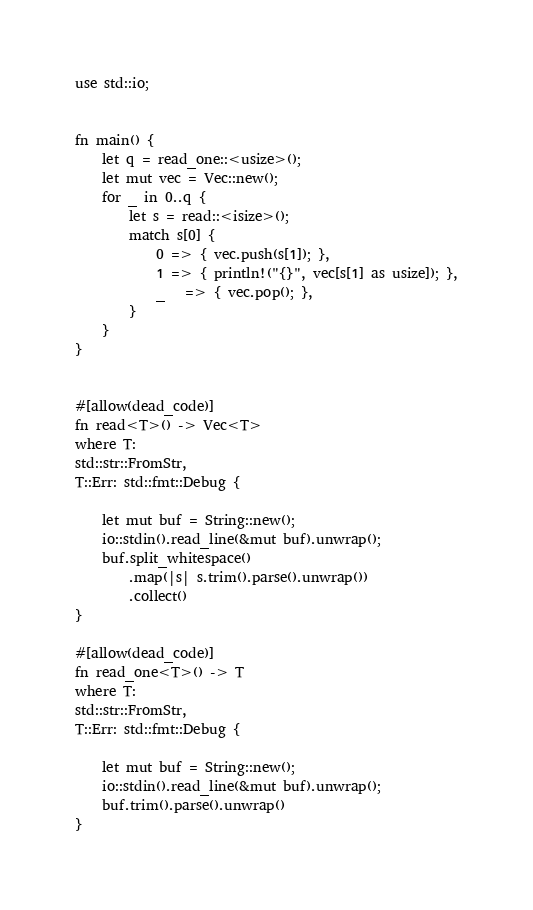<code> <loc_0><loc_0><loc_500><loc_500><_Rust_>use std::io;


fn main() {
    let q = read_one::<usize>();
    let mut vec = Vec::new();
    for _ in 0..q {
        let s = read::<isize>();
        match s[0] {
            0 => { vec.push(s[1]); },
            1 => { println!("{}", vec[s[1] as usize]); },
            _   => { vec.pop(); },
        }
    }
}


#[allow(dead_code)]
fn read<T>() -> Vec<T>
where T:
std::str::FromStr,
T::Err: std::fmt::Debug {

    let mut buf = String::new();
    io::stdin().read_line(&mut buf).unwrap();
    buf.split_whitespace()
        .map(|s| s.trim().parse().unwrap())
        .collect()
}

#[allow(dead_code)]
fn read_one<T>() -> T
where T:
std::str::FromStr,
T::Err: std::fmt::Debug {

    let mut buf = String::new();
    io::stdin().read_line(&mut buf).unwrap();
    buf.trim().parse().unwrap()
}
</code> 